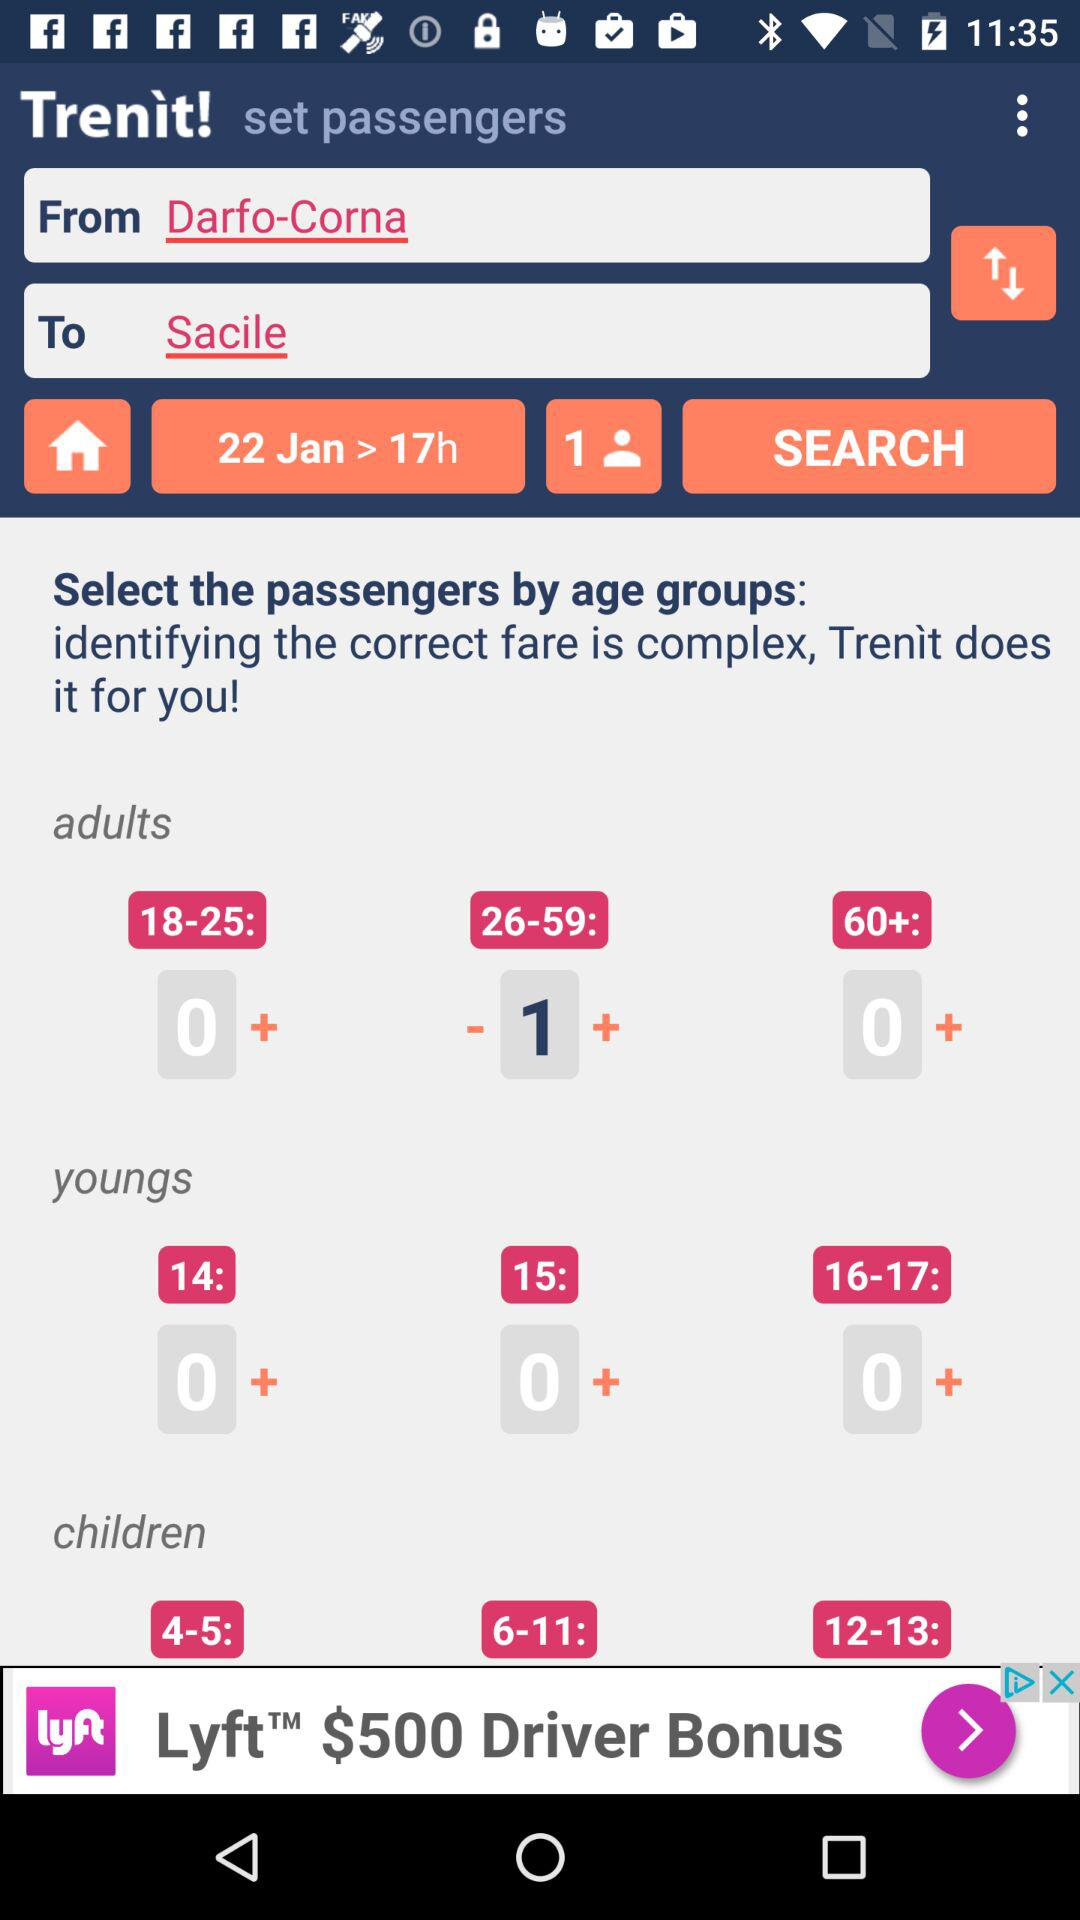How many passengers are selected in the age group of 26-59? The number of selected passengers is 1. 